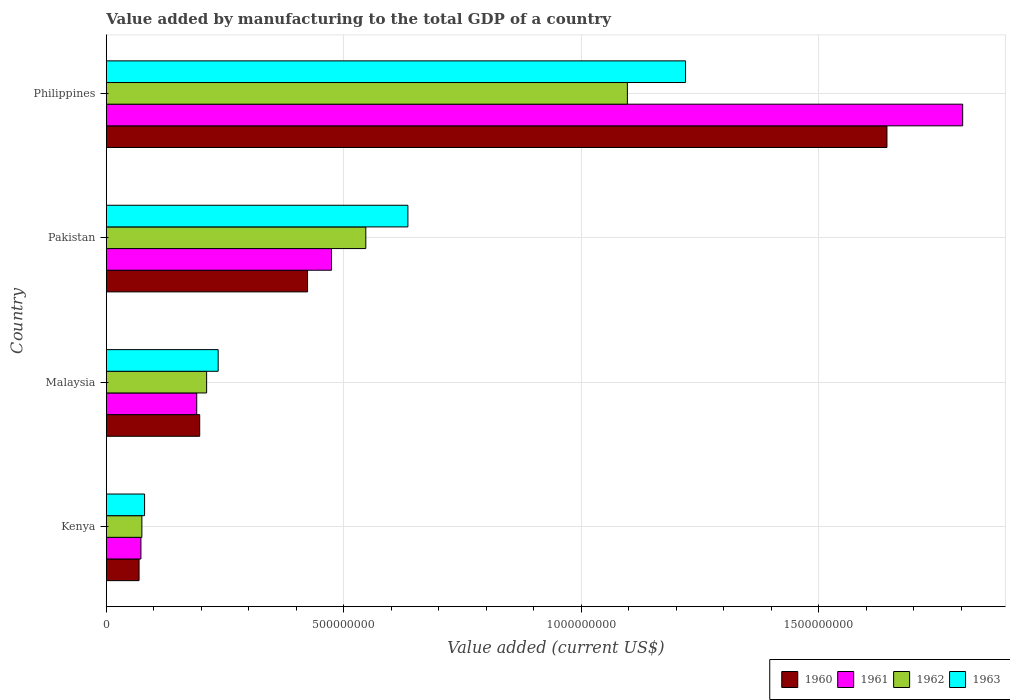How many different coloured bars are there?
Provide a short and direct response. 4. How many groups of bars are there?
Your response must be concise. 4. Are the number of bars per tick equal to the number of legend labels?
Keep it short and to the point. Yes. Are the number of bars on each tick of the Y-axis equal?
Ensure brevity in your answer.  Yes. How many bars are there on the 2nd tick from the top?
Offer a very short reply. 4. What is the value added by manufacturing to the total GDP in 1963 in Philippines?
Make the answer very short. 1.22e+09. Across all countries, what is the maximum value added by manufacturing to the total GDP in 1963?
Offer a terse response. 1.22e+09. Across all countries, what is the minimum value added by manufacturing to the total GDP in 1961?
Your answer should be very brief. 7.28e+07. In which country was the value added by manufacturing to the total GDP in 1963 minimum?
Your answer should be compact. Kenya. What is the total value added by manufacturing to the total GDP in 1960 in the graph?
Give a very brief answer. 2.33e+09. What is the difference between the value added by manufacturing to the total GDP in 1960 in Kenya and that in Pakistan?
Offer a very short reply. -3.55e+08. What is the difference between the value added by manufacturing to the total GDP in 1960 in Malaysia and the value added by manufacturing to the total GDP in 1963 in Kenya?
Offer a terse response. 1.16e+08. What is the average value added by manufacturing to the total GDP in 1962 per country?
Ensure brevity in your answer.  4.82e+08. What is the difference between the value added by manufacturing to the total GDP in 1960 and value added by manufacturing to the total GDP in 1962 in Pakistan?
Provide a short and direct response. -1.23e+08. In how many countries, is the value added by manufacturing to the total GDP in 1961 greater than 400000000 US$?
Ensure brevity in your answer.  2. What is the ratio of the value added by manufacturing to the total GDP in 1961 in Kenya to that in Malaysia?
Offer a terse response. 0.38. Is the value added by manufacturing to the total GDP in 1963 in Kenya less than that in Philippines?
Offer a terse response. Yes. What is the difference between the highest and the second highest value added by manufacturing to the total GDP in 1963?
Provide a succinct answer. 5.85e+08. What is the difference between the highest and the lowest value added by manufacturing to the total GDP in 1960?
Give a very brief answer. 1.57e+09. What does the 3rd bar from the top in Malaysia represents?
Offer a very short reply. 1961. What does the 1st bar from the bottom in Malaysia represents?
Make the answer very short. 1960. Are all the bars in the graph horizontal?
Your response must be concise. Yes. How many countries are there in the graph?
Your answer should be very brief. 4. Does the graph contain any zero values?
Ensure brevity in your answer.  No. Where does the legend appear in the graph?
Keep it short and to the point. Bottom right. How many legend labels are there?
Ensure brevity in your answer.  4. How are the legend labels stacked?
Provide a succinct answer. Horizontal. What is the title of the graph?
Ensure brevity in your answer.  Value added by manufacturing to the total GDP of a country. Does "1983" appear as one of the legend labels in the graph?
Make the answer very short. No. What is the label or title of the X-axis?
Offer a very short reply. Value added (current US$). What is the label or title of the Y-axis?
Keep it short and to the point. Country. What is the Value added (current US$) in 1960 in Kenya?
Keep it short and to the point. 6.89e+07. What is the Value added (current US$) in 1961 in Kenya?
Your answer should be very brief. 7.28e+07. What is the Value added (current US$) of 1962 in Kenya?
Keep it short and to the point. 7.48e+07. What is the Value added (current US$) of 1963 in Kenya?
Offer a very short reply. 8.05e+07. What is the Value added (current US$) in 1960 in Malaysia?
Provide a succinct answer. 1.97e+08. What is the Value added (current US$) in 1961 in Malaysia?
Give a very brief answer. 1.90e+08. What is the Value added (current US$) in 1962 in Malaysia?
Provide a short and direct response. 2.11e+08. What is the Value added (current US$) of 1963 in Malaysia?
Your response must be concise. 2.36e+08. What is the Value added (current US$) of 1960 in Pakistan?
Make the answer very short. 4.24e+08. What is the Value added (current US$) of 1961 in Pakistan?
Provide a short and direct response. 4.74e+08. What is the Value added (current US$) in 1962 in Pakistan?
Ensure brevity in your answer.  5.46e+08. What is the Value added (current US$) in 1963 in Pakistan?
Provide a succinct answer. 6.35e+08. What is the Value added (current US$) of 1960 in Philippines?
Your answer should be compact. 1.64e+09. What is the Value added (current US$) in 1961 in Philippines?
Provide a succinct answer. 1.80e+09. What is the Value added (current US$) of 1962 in Philippines?
Your answer should be very brief. 1.10e+09. What is the Value added (current US$) in 1963 in Philippines?
Your answer should be compact. 1.22e+09. Across all countries, what is the maximum Value added (current US$) in 1960?
Make the answer very short. 1.64e+09. Across all countries, what is the maximum Value added (current US$) in 1961?
Provide a short and direct response. 1.80e+09. Across all countries, what is the maximum Value added (current US$) of 1962?
Provide a succinct answer. 1.10e+09. Across all countries, what is the maximum Value added (current US$) in 1963?
Provide a short and direct response. 1.22e+09. Across all countries, what is the minimum Value added (current US$) of 1960?
Ensure brevity in your answer.  6.89e+07. Across all countries, what is the minimum Value added (current US$) of 1961?
Keep it short and to the point. 7.28e+07. Across all countries, what is the minimum Value added (current US$) in 1962?
Provide a succinct answer. 7.48e+07. Across all countries, what is the minimum Value added (current US$) of 1963?
Ensure brevity in your answer.  8.05e+07. What is the total Value added (current US$) in 1960 in the graph?
Keep it short and to the point. 2.33e+09. What is the total Value added (current US$) in 1961 in the graph?
Ensure brevity in your answer.  2.54e+09. What is the total Value added (current US$) of 1962 in the graph?
Provide a succinct answer. 1.93e+09. What is the total Value added (current US$) of 1963 in the graph?
Provide a succinct answer. 2.17e+09. What is the difference between the Value added (current US$) of 1960 in Kenya and that in Malaysia?
Provide a succinct answer. -1.28e+08. What is the difference between the Value added (current US$) of 1961 in Kenya and that in Malaysia?
Make the answer very short. -1.18e+08. What is the difference between the Value added (current US$) in 1962 in Kenya and that in Malaysia?
Provide a short and direct response. -1.36e+08. What is the difference between the Value added (current US$) of 1963 in Kenya and that in Malaysia?
Make the answer very short. -1.55e+08. What is the difference between the Value added (current US$) in 1960 in Kenya and that in Pakistan?
Your answer should be compact. -3.55e+08. What is the difference between the Value added (current US$) in 1961 in Kenya and that in Pakistan?
Provide a succinct answer. -4.01e+08. What is the difference between the Value added (current US$) in 1962 in Kenya and that in Pakistan?
Provide a short and direct response. -4.72e+08. What is the difference between the Value added (current US$) in 1963 in Kenya and that in Pakistan?
Provide a succinct answer. -5.54e+08. What is the difference between the Value added (current US$) of 1960 in Kenya and that in Philippines?
Make the answer very short. -1.57e+09. What is the difference between the Value added (current US$) in 1961 in Kenya and that in Philippines?
Ensure brevity in your answer.  -1.73e+09. What is the difference between the Value added (current US$) of 1962 in Kenya and that in Philippines?
Your response must be concise. -1.02e+09. What is the difference between the Value added (current US$) in 1963 in Kenya and that in Philippines?
Offer a terse response. -1.14e+09. What is the difference between the Value added (current US$) of 1960 in Malaysia and that in Pakistan?
Offer a terse response. -2.27e+08. What is the difference between the Value added (current US$) in 1961 in Malaysia and that in Pakistan?
Offer a very short reply. -2.84e+08. What is the difference between the Value added (current US$) of 1962 in Malaysia and that in Pakistan?
Your answer should be very brief. -3.35e+08. What is the difference between the Value added (current US$) in 1963 in Malaysia and that in Pakistan?
Give a very brief answer. -3.99e+08. What is the difference between the Value added (current US$) in 1960 in Malaysia and that in Philippines?
Make the answer very short. -1.45e+09. What is the difference between the Value added (current US$) of 1961 in Malaysia and that in Philippines?
Your answer should be very brief. -1.61e+09. What is the difference between the Value added (current US$) of 1962 in Malaysia and that in Philippines?
Keep it short and to the point. -8.86e+08. What is the difference between the Value added (current US$) of 1963 in Malaysia and that in Philippines?
Your response must be concise. -9.84e+08. What is the difference between the Value added (current US$) of 1960 in Pakistan and that in Philippines?
Your answer should be compact. -1.22e+09. What is the difference between the Value added (current US$) in 1961 in Pakistan and that in Philippines?
Give a very brief answer. -1.33e+09. What is the difference between the Value added (current US$) in 1962 in Pakistan and that in Philippines?
Offer a terse response. -5.51e+08. What is the difference between the Value added (current US$) of 1963 in Pakistan and that in Philippines?
Offer a very short reply. -5.85e+08. What is the difference between the Value added (current US$) of 1960 in Kenya and the Value added (current US$) of 1961 in Malaysia?
Give a very brief answer. -1.21e+08. What is the difference between the Value added (current US$) of 1960 in Kenya and the Value added (current US$) of 1962 in Malaysia?
Provide a short and direct response. -1.42e+08. What is the difference between the Value added (current US$) of 1960 in Kenya and the Value added (current US$) of 1963 in Malaysia?
Your answer should be very brief. -1.67e+08. What is the difference between the Value added (current US$) in 1961 in Kenya and the Value added (current US$) in 1962 in Malaysia?
Make the answer very short. -1.38e+08. What is the difference between the Value added (current US$) of 1961 in Kenya and the Value added (current US$) of 1963 in Malaysia?
Give a very brief answer. -1.63e+08. What is the difference between the Value added (current US$) in 1962 in Kenya and the Value added (current US$) in 1963 in Malaysia?
Offer a terse response. -1.61e+08. What is the difference between the Value added (current US$) in 1960 in Kenya and the Value added (current US$) in 1961 in Pakistan?
Ensure brevity in your answer.  -4.05e+08. What is the difference between the Value added (current US$) of 1960 in Kenya and the Value added (current US$) of 1962 in Pakistan?
Keep it short and to the point. -4.78e+08. What is the difference between the Value added (current US$) of 1960 in Kenya and the Value added (current US$) of 1963 in Pakistan?
Ensure brevity in your answer.  -5.66e+08. What is the difference between the Value added (current US$) of 1961 in Kenya and the Value added (current US$) of 1962 in Pakistan?
Give a very brief answer. -4.74e+08. What is the difference between the Value added (current US$) of 1961 in Kenya and the Value added (current US$) of 1963 in Pakistan?
Give a very brief answer. -5.62e+08. What is the difference between the Value added (current US$) of 1962 in Kenya and the Value added (current US$) of 1963 in Pakistan?
Your answer should be compact. -5.60e+08. What is the difference between the Value added (current US$) in 1960 in Kenya and the Value added (current US$) in 1961 in Philippines?
Ensure brevity in your answer.  -1.73e+09. What is the difference between the Value added (current US$) in 1960 in Kenya and the Value added (current US$) in 1962 in Philippines?
Ensure brevity in your answer.  -1.03e+09. What is the difference between the Value added (current US$) in 1960 in Kenya and the Value added (current US$) in 1963 in Philippines?
Keep it short and to the point. -1.15e+09. What is the difference between the Value added (current US$) in 1961 in Kenya and the Value added (current US$) in 1962 in Philippines?
Provide a short and direct response. -1.02e+09. What is the difference between the Value added (current US$) of 1961 in Kenya and the Value added (current US$) of 1963 in Philippines?
Offer a terse response. -1.15e+09. What is the difference between the Value added (current US$) in 1962 in Kenya and the Value added (current US$) in 1963 in Philippines?
Offer a very short reply. -1.14e+09. What is the difference between the Value added (current US$) in 1960 in Malaysia and the Value added (current US$) in 1961 in Pakistan?
Keep it short and to the point. -2.78e+08. What is the difference between the Value added (current US$) in 1960 in Malaysia and the Value added (current US$) in 1962 in Pakistan?
Keep it short and to the point. -3.50e+08. What is the difference between the Value added (current US$) of 1960 in Malaysia and the Value added (current US$) of 1963 in Pakistan?
Give a very brief answer. -4.38e+08. What is the difference between the Value added (current US$) in 1961 in Malaysia and the Value added (current US$) in 1962 in Pakistan?
Your answer should be compact. -3.56e+08. What is the difference between the Value added (current US$) in 1961 in Malaysia and the Value added (current US$) in 1963 in Pakistan?
Your answer should be compact. -4.45e+08. What is the difference between the Value added (current US$) of 1962 in Malaysia and the Value added (current US$) of 1963 in Pakistan?
Make the answer very short. -4.24e+08. What is the difference between the Value added (current US$) of 1960 in Malaysia and the Value added (current US$) of 1961 in Philippines?
Offer a terse response. -1.61e+09. What is the difference between the Value added (current US$) of 1960 in Malaysia and the Value added (current US$) of 1962 in Philippines?
Keep it short and to the point. -9.01e+08. What is the difference between the Value added (current US$) in 1960 in Malaysia and the Value added (current US$) in 1963 in Philippines?
Provide a short and direct response. -1.02e+09. What is the difference between the Value added (current US$) of 1961 in Malaysia and the Value added (current US$) of 1962 in Philippines?
Your answer should be compact. -9.07e+08. What is the difference between the Value added (current US$) of 1961 in Malaysia and the Value added (current US$) of 1963 in Philippines?
Your answer should be compact. -1.03e+09. What is the difference between the Value added (current US$) of 1962 in Malaysia and the Value added (current US$) of 1963 in Philippines?
Offer a very short reply. -1.01e+09. What is the difference between the Value added (current US$) in 1960 in Pakistan and the Value added (current US$) in 1961 in Philippines?
Provide a succinct answer. -1.38e+09. What is the difference between the Value added (current US$) in 1960 in Pakistan and the Value added (current US$) in 1962 in Philippines?
Your answer should be compact. -6.74e+08. What is the difference between the Value added (current US$) in 1960 in Pakistan and the Value added (current US$) in 1963 in Philippines?
Provide a succinct answer. -7.96e+08. What is the difference between the Value added (current US$) in 1961 in Pakistan and the Value added (current US$) in 1962 in Philippines?
Offer a very short reply. -6.23e+08. What is the difference between the Value added (current US$) of 1961 in Pakistan and the Value added (current US$) of 1963 in Philippines?
Provide a short and direct response. -7.46e+08. What is the difference between the Value added (current US$) of 1962 in Pakistan and the Value added (current US$) of 1963 in Philippines?
Make the answer very short. -6.73e+08. What is the average Value added (current US$) of 1960 per country?
Give a very brief answer. 5.83e+08. What is the average Value added (current US$) in 1961 per country?
Your answer should be compact. 6.35e+08. What is the average Value added (current US$) of 1962 per country?
Provide a succinct answer. 4.82e+08. What is the average Value added (current US$) of 1963 per country?
Make the answer very short. 5.43e+08. What is the difference between the Value added (current US$) of 1960 and Value added (current US$) of 1961 in Kenya?
Provide a succinct answer. -3.93e+06. What is the difference between the Value added (current US$) in 1960 and Value added (current US$) in 1962 in Kenya?
Give a very brief answer. -5.94e+06. What is the difference between the Value added (current US$) of 1960 and Value added (current US$) of 1963 in Kenya?
Your answer should be compact. -1.16e+07. What is the difference between the Value added (current US$) of 1961 and Value added (current US$) of 1962 in Kenya?
Keep it short and to the point. -2.00e+06. What is the difference between the Value added (current US$) in 1961 and Value added (current US$) in 1963 in Kenya?
Offer a very short reply. -7.70e+06. What is the difference between the Value added (current US$) of 1962 and Value added (current US$) of 1963 in Kenya?
Your answer should be very brief. -5.70e+06. What is the difference between the Value added (current US$) in 1960 and Value added (current US$) in 1961 in Malaysia?
Keep it short and to the point. 6.25e+06. What is the difference between the Value added (current US$) of 1960 and Value added (current US$) of 1962 in Malaysia?
Provide a short and direct response. -1.46e+07. What is the difference between the Value added (current US$) in 1960 and Value added (current US$) in 1963 in Malaysia?
Give a very brief answer. -3.89e+07. What is the difference between the Value added (current US$) of 1961 and Value added (current US$) of 1962 in Malaysia?
Your answer should be very brief. -2.08e+07. What is the difference between the Value added (current US$) in 1961 and Value added (current US$) in 1963 in Malaysia?
Give a very brief answer. -4.52e+07. What is the difference between the Value added (current US$) of 1962 and Value added (current US$) of 1963 in Malaysia?
Your response must be concise. -2.43e+07. What is the difference between the Value added (current US$) in 1960 and Value added (current US$) in 1961 in Pakistan?
Offer a very short reply. -5.04e+07. What is the difference between the Value added (current US$) of 1960 and Value added (current US$) of 1962 in Pakistan?
Keep it short and to the point. -1.23e+08. What is the difference between the Value added (current US$) of 1960 and Value added (current US$) of 1963 in Pakistan?
Keep it short and to the point. -2.11e+08. What is the difference between the Value added (current US$) in 1961 and Value added (current US$) in 1962 in Pakistan?
Provide a short and direct response. -7.22e+07. What is the difference between the Value added (current US$) in 1961 and Value added (current US$) in 1963 in Pakistan?
Make the answer very short. -1.61e+08. What is the difference between the Value added (current US$) of 1962 and Value added (current US$) of 1963 in Pakistan?
Provide a succinct answer. -8.86e+07. What is the difference between the Value added (current US$) of 1960 and Value added (current US$) of 1961 in Philippines?
Make the answer very short. -1.59e+08. What is the difference between the Value added (current US$) in 1960 and Value added (current US$) in 1962 in Philippines?
Your answer should be very brief. 5.47e+08. What is the difference between the Value added (current US$) in 1960 and Value added (current US$) in 1963 in Philippines?
Provide a short and direct response. 4.24e+08. What is the difference between the Value added (current US$) of 1961 and Value added (current US$) of 1962 in Philippines?
Provide a short and direct response. 7.06e+08. What is the difference between the Value added (current US$) in 1961 and Value added (current US$) in 1963 in Philippines?
Offer a terse response. 5.84e+08. What is the difference between the Value added (current US$) in 1962 and Value added (current US$) in 1963 in Philippines?
Offer a very short reply. -1.22e+08. What is the ratio of the Value added (current US$) in 1960 in Kenya to that in Malaysia?
Your response must be concise. 0.35. What is the ratio of the Value added (current US$) of 1961 in Kenya to that in Malaysia?
Your response must be concise. 0.38. What is the ratio of the Value added (current US$) in 1962 in Kenya to that in Malaysia?
Provide a succinct answer. 0.35. What is the ratio of the Value added (current US$) of 1963 in Kenya to that in Malaysia?
Ensure brevity in your answer.  0.34. What is the ratio of the Value added (current US$) in 1960 in Kenya to that in Pakistan?
Provide a short and direct response. 0.16. What is the ratio of the Value added (current US$) of 1961 in Kenya to that in Pakistan?
Your response must be concise. 0.15. What is the ratio of the Value added (current US$) of 1962 in Kenya to that in Pakistan?
Your response must be concise. 0.14. What is the ratio of the Value added (current US$) of 1963 in Kenya to that in Pakistan?
Your answer should be compact. 0.13. What is the ratio of the Value added (current US$) in 1960 in Kenya to that in Philippines?
Ensure brevity in your answer.  0.04. What is the ratio of the Value added (current US$) of 1961 in Kenya to that in Philippines?
Ensure brevity in your answer.  0.04. What is the ratio of the Value added (current US$) of 1962 in Kenya to that in Philippines?
Keep it short and to the point. 0.07. What is the ratio of the Value added (current US$) of 1963 in Kenya to that in Philippines?
Your response must be concise. 0.07. What is the ratio of the Value added (current US$) in 1960 in Malaysia to that in Pakistan?
Keep it short and to the point. 0.46. What is the ratio of the Value added (current US$) in 1961 in Malaysia to that in Pakistan?
Give a very brief answer. 0.4. What is the ratio of the Value added (current US$) in 1962 in Malaysia to that in Pakistan?
Provide a succinct answer. 0.39. What is the ratio of the Value added (current US$) in 1963 in Malaysia to that in Pakistan?
Your answer should be very brief. 0.37. What is the ratio of the Value added (current US$) of 1960 in Malaysia to that in Philippines?
Offer a terse response. 0.12. What is the ratio of the Value added (current US$) in 1961 in Malaysia to that in Philippines?
Your answer should be compact. 0.11. What is the ratio of the Value added (current US$) in 1962 in Malaysia to that in Philippines?
Offer a very short reply. 0.19. What is the ratio of the Value added (current US$) in 1963 in Malaysia to that in Philippines?
Provide a short and direct response. 0.19. What is the ratio of the Value added (current US$) in 1960 in Pakistan to that in Philippines?
Offer a terse response. 0.26. What is the ratio of the Value added (current US$) in 1961 in Pakistan to that in Philippines?
Your response must be concise. 0.26. What is the ratio of the Value added (current US$) of 1962 in Pakistan to that in Philippines?
Give a very brief answer. 0.5. What is the ratio of the Value added (current US$) in 1963 in Pakistan to that in Philippines?
Your answer should be compact. 0.52. What is the difference between the highest and the second highest Value added (current US$) in 1960?
Offer a terse response. 1.22e+09. What is the difference between the highest and the second highest Value added (current US$) in 1961?
Your answer should be compact. 1.33e+09. What is the difference between the highest and the second highest Value added (current US$) in 1962?
Ensure brevity in your answer.  5.51e+08. What is the difference between the highest and the second highest Value added (current US$) in 1963?
Your response must be concise. 5.85e+08. What is the difference between the highest and the lowest Value added (current US$) in 1960?
Your answer should be very brief. 1.57e+09. What is the difference between the highest and the lowest Value added (current US$) in 1961?
Ensure brevity in your answer.  1.73e+09. What is the difference between the highest and the lowest Value added (current US$) of 1962?
Provide a succinct answer. 1.02e+09. What is the difference between the highest and the lowest Value added (current US$) of 1963?
Offer a very short reply. 1.14e+09. 